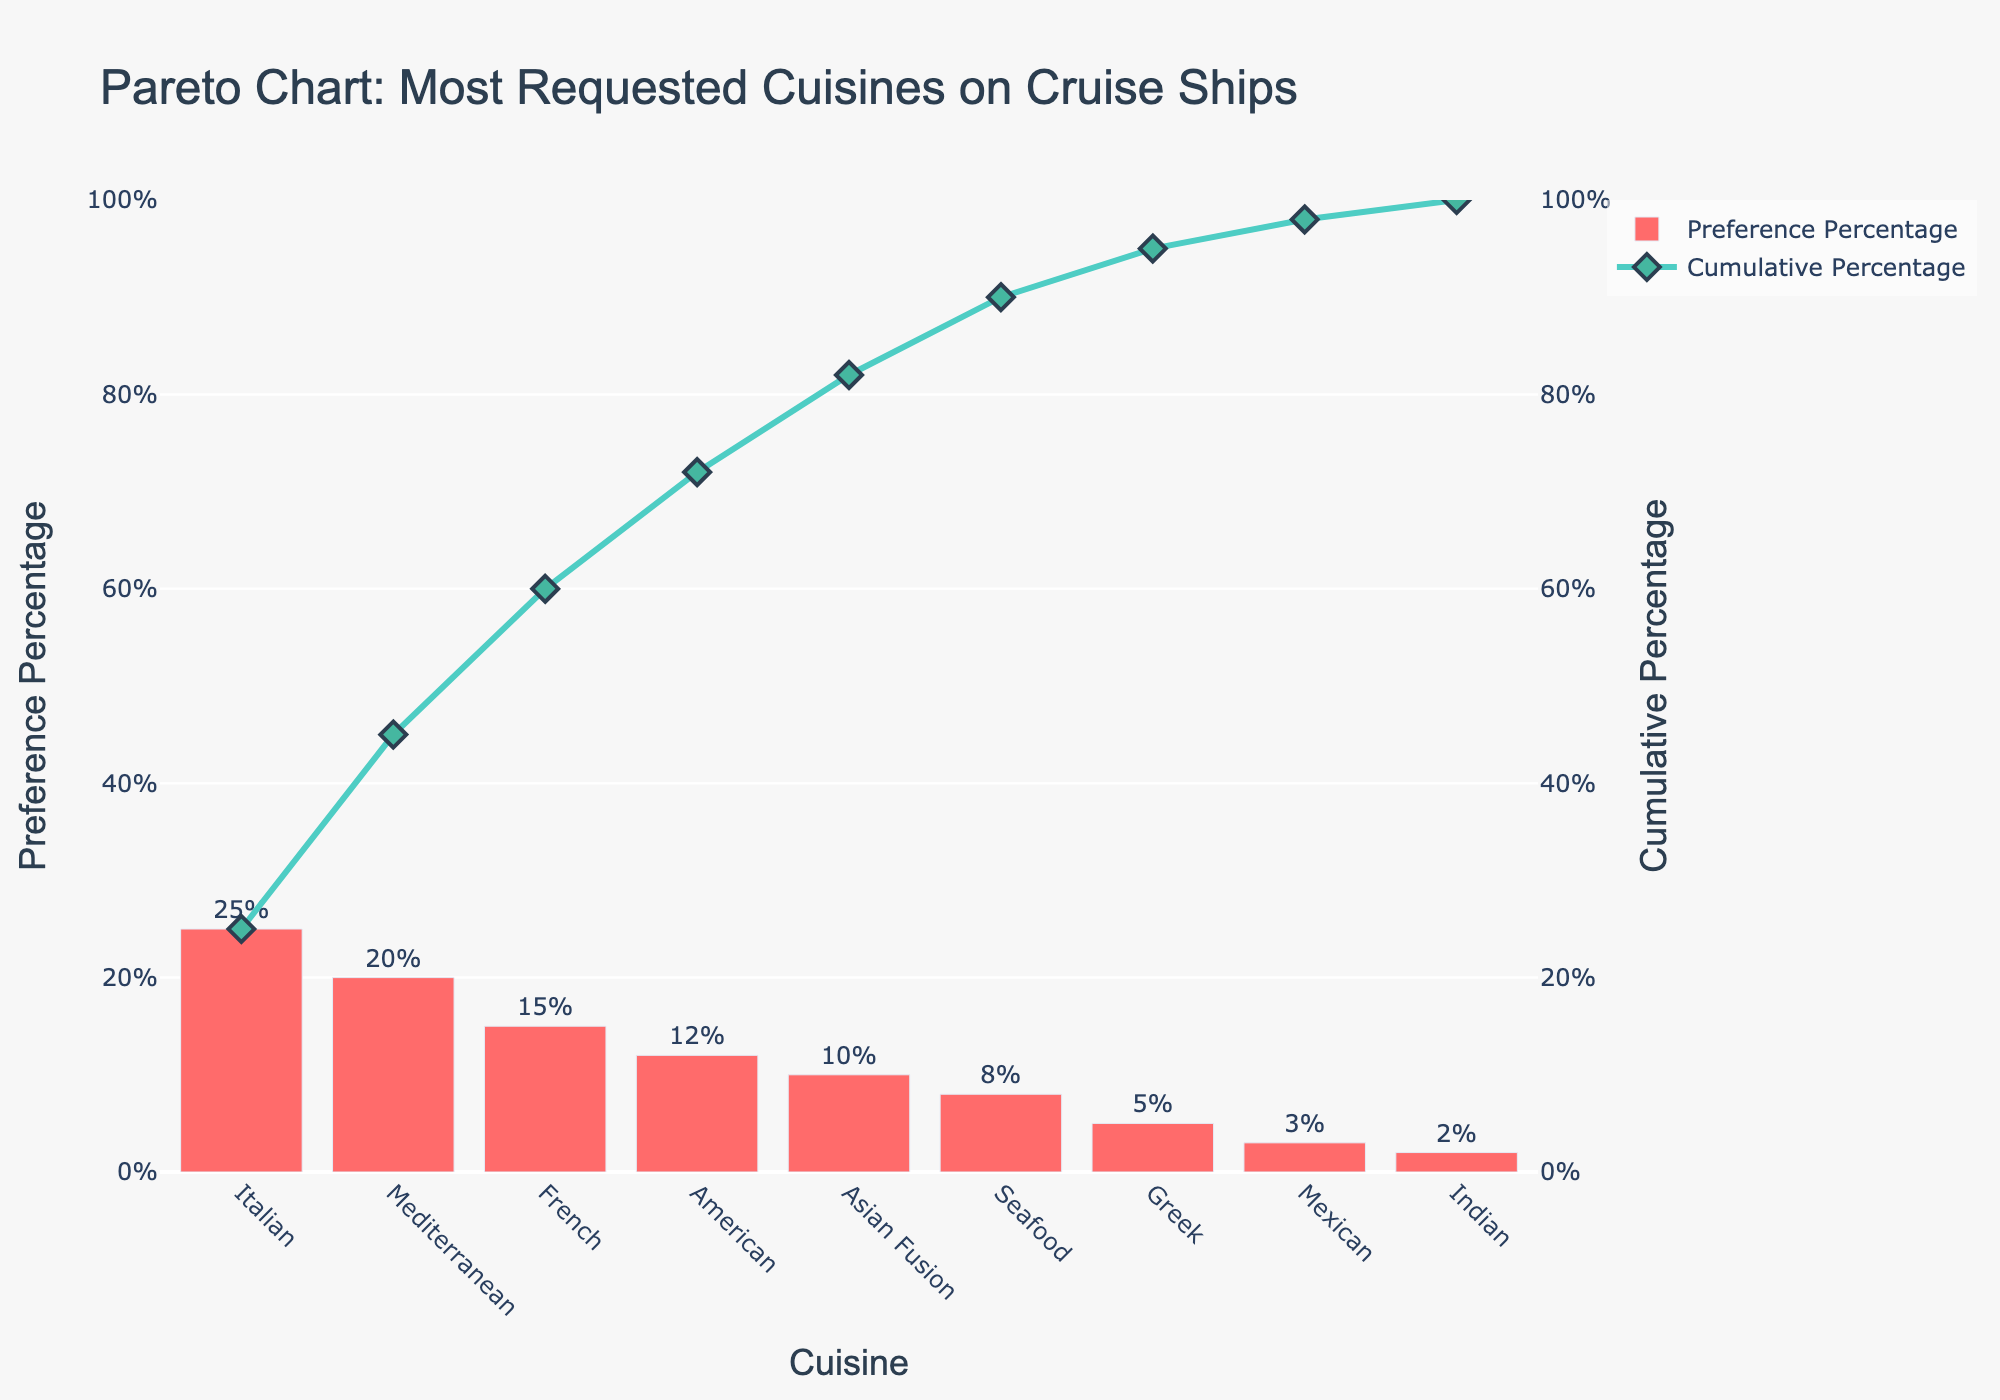What's the most requested cuisine on cruise ships according to the chart? The chart shows the bar representing Italian cuisine is the highest, labeled with 25%. Thus, Italian is the most requested.
Answer: Italian What's the primary color used in the bar for preference percentage? The color of the bars representing preference percentages is a bright red tone, identifiable as '#FF6B6B'.
Answer: Red What is the cumulative percentage at the French cuisine? The cumulative percentage is listed on the right y-axis. For French cuisine, the line graph shows the cumulative percentage at 60%.
Answer: 60% What's the total percentage of requests for Asian Fusion and Seafood cuisines combined? Asian Fusion has 10% and Seafood has 8%. By adding these percentages, the total is 10% + 8% = 18%.
Answer: 18% Between Greek and Mexican cuisines, which has a higher passenger preference? The chart shows the bar for Greek cuisine at 5% and the bar for Mexican cuisine at 3%. Thus, Greek cuisine has higher passenger preference.
Answer: Greek If you combined the preferences for Mediterranean and American cuisines, would they surpass Italian cuisine's preference? Mediterranean prefers 20% and American 12%, summing up to 32%. Italian cuisine alone has 25%. Since 32% > 25%, they would surpass Italian cuisine's preference.
Answer: Yes What is the least requested cuisine on cruise ships according to the chart? The least requested cuisine, represented by the shortest bar at the far right, is Indian with 2%.
Answer: Indian How does the cumulative percentage progress with each cuisine listed in descending order of preference? Start with Italian (25%), then add Mediterranean (45%), then French (60%), American (72%), Asian Fusion (82%), Seafood (90%), Greek (95%), Mexican (98%), and finally Indian (100%).
Answer: 25%, 45%, 60%, 72%, 82%, 90%, 95%, 98%, 100% How many cuisines have a preference percentage of at least 10%? By looking at the bars, Italian, Mediterranean, French, American, and Asian Fusion all have percentages of 10% or more. This totals to 5 cuisines.
Answer: 5 Why does the line graph stop at 100% for the cumulative percentage? The cumulative percentage represents the accumulation of all preference percentages and must sum to 100%. Each cuisine's preference % adds to the previous, maxing out at 100% when all cuisines are included.
Answer: Cumulative total 